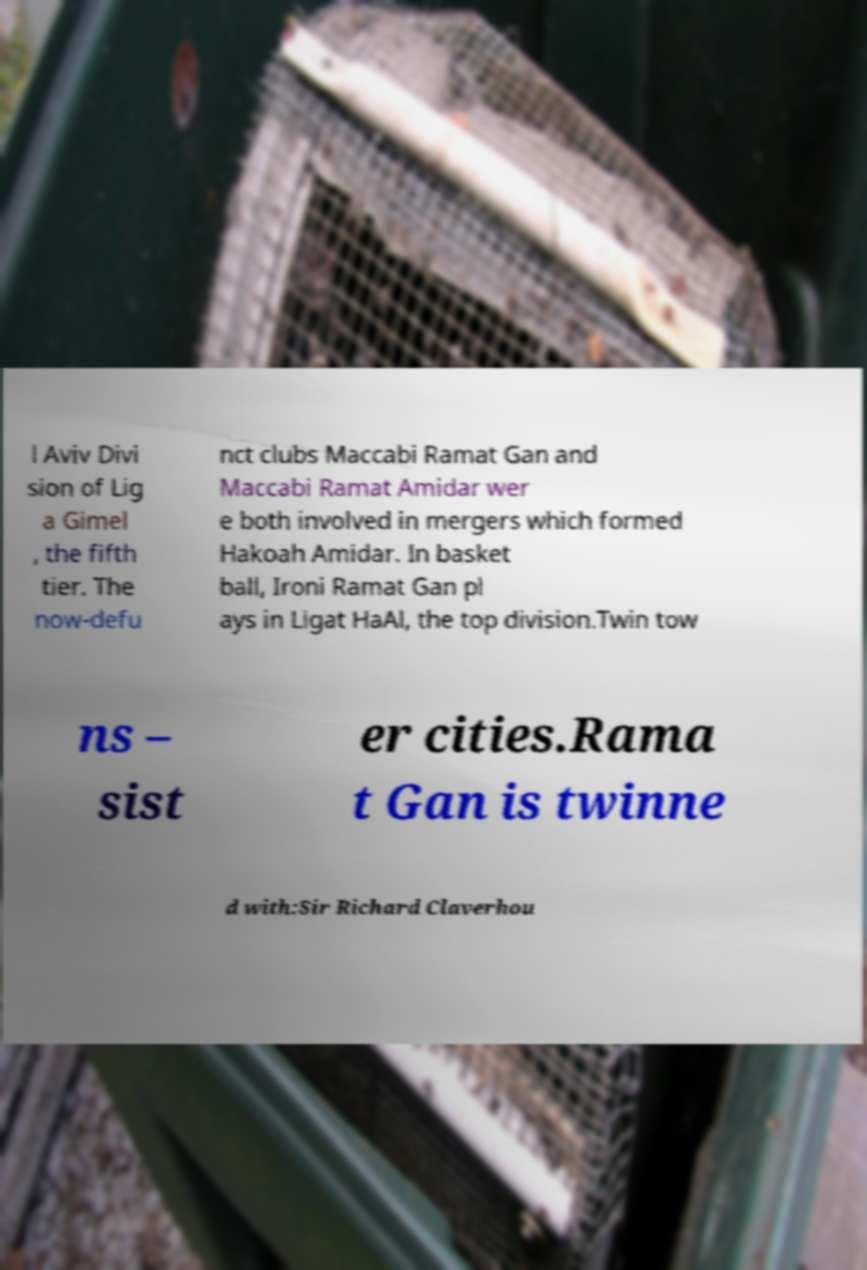I need the written content from this picture converted into text. Can you do that? l Aviv Divi sion of Lig a Gimel , the fifth tier. The now-defu nct clubs Maccabi Ramat Gan and Maccabi Ramat Amidar wer e both involved in mergers which formed Hakoah Amidar. In basket ball, Ironi Ramat Gan pl ays in Ligat HaAl, the top division.Twin tow ns – sist er cities.Rama t Gan is twinne d with:Sir Richard Claverhou 